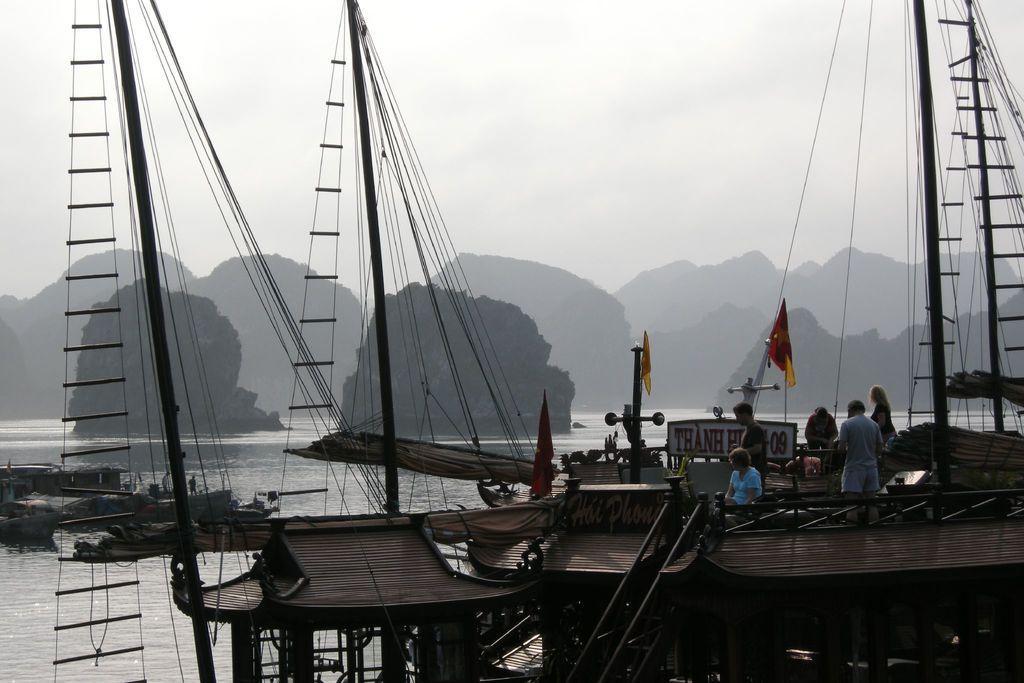How would you summarize this image in a sentence or two? In the image in the center we can see few boats. On boats,we can see flags and few people. In the background we can see sky,clouds,hill,trees,water and few boats. 